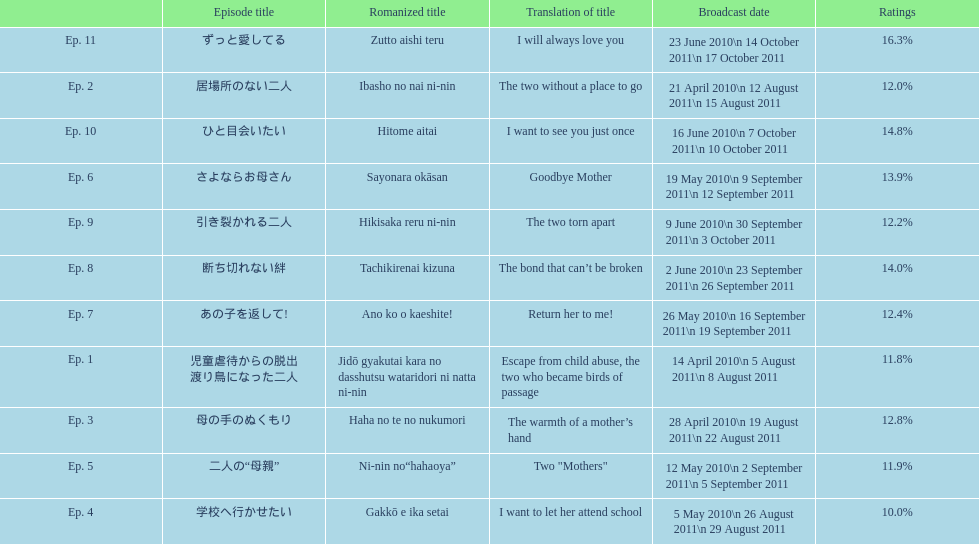What were the episode titles of mother? 児童虐待からの脱出 渡り鳥になった二人, 居場所のない二人, 母の手のぬくもり, 学校へ行かせたい, 二人の“母親”, さよならお母さん, あの子を返して!, 断ち切れない絆, 引き裂かれる二人, ひと目会いたい, ずっと愛してる. Which of these episodes had the highest ratings? ずっと愛してる. 